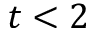<formula> <loc_0><loc_0><loc_500><loc_500>t < 2</formula> 